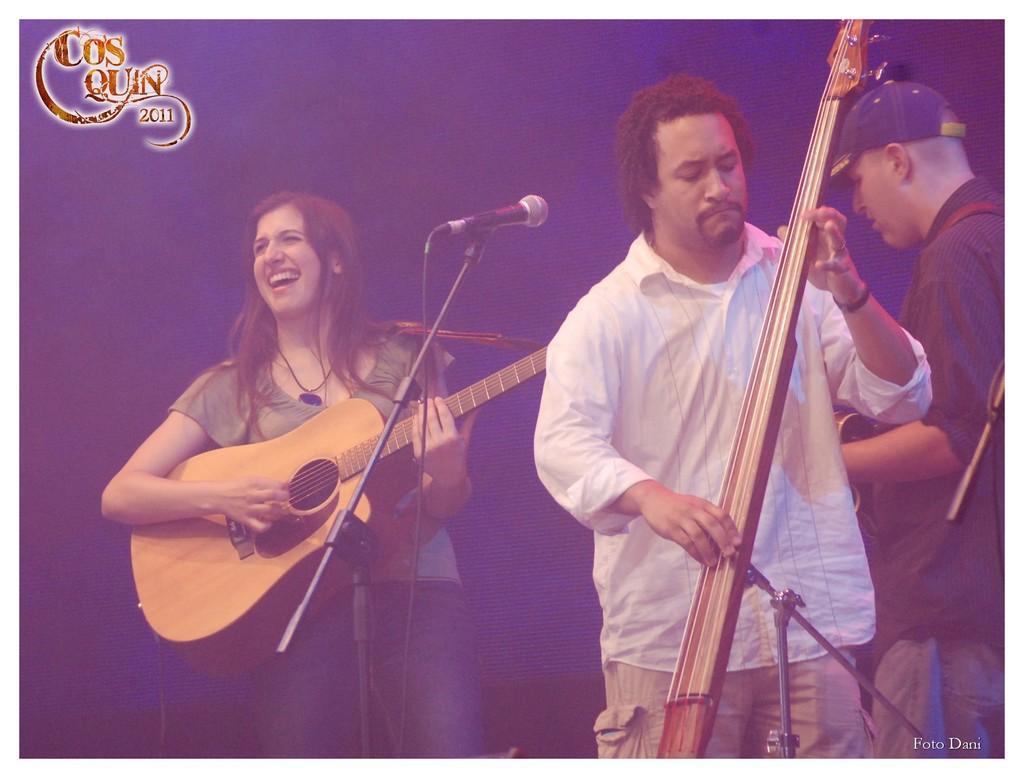Could you give a brief overview of what you see in this image? Here is the woman standing and playing guitar. There are two people standing,one person is holding a musical instrument. This is the mike with the mike stand. I think this person is holding guitar. And the background looks dark. 